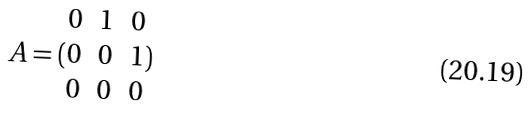<formula> <loc_0><loc_0><loc_500><loc_500>A = ( \begin{matrix} 0 & 1 & 0 \\ 0 & 0 & 1 \\ 0 & 0 & 0 \end{matrix} )</formula> 